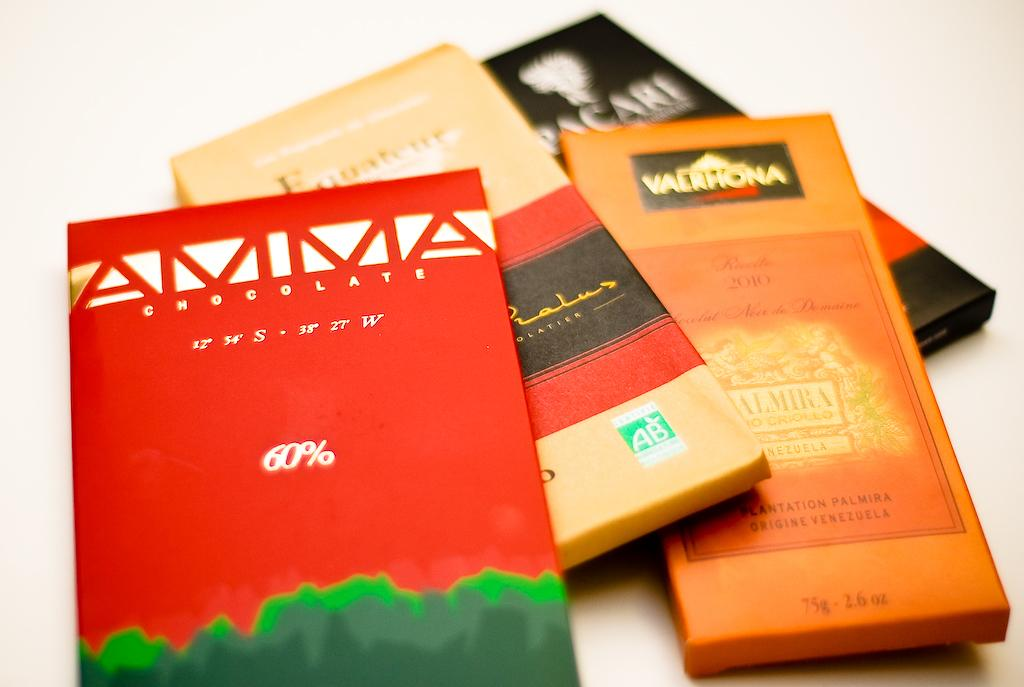<image>
Describe the image concisely. A red card for chocolate has 60% in white. 